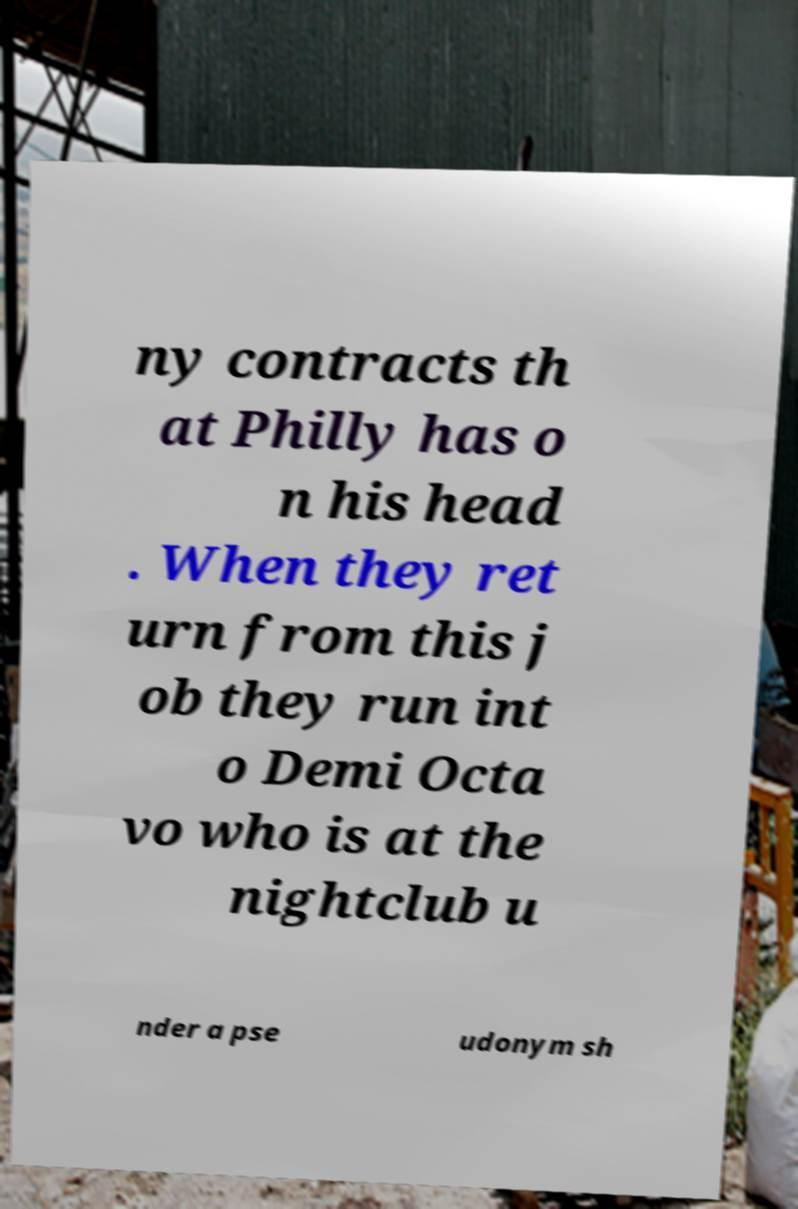Please identify and transcribe the text found in this image. ny contracts th at Philly has o n his head . When they ret urn from this j ob they run int o Demi Octa vo who is at the nightclub u nder a pse udonym sh 